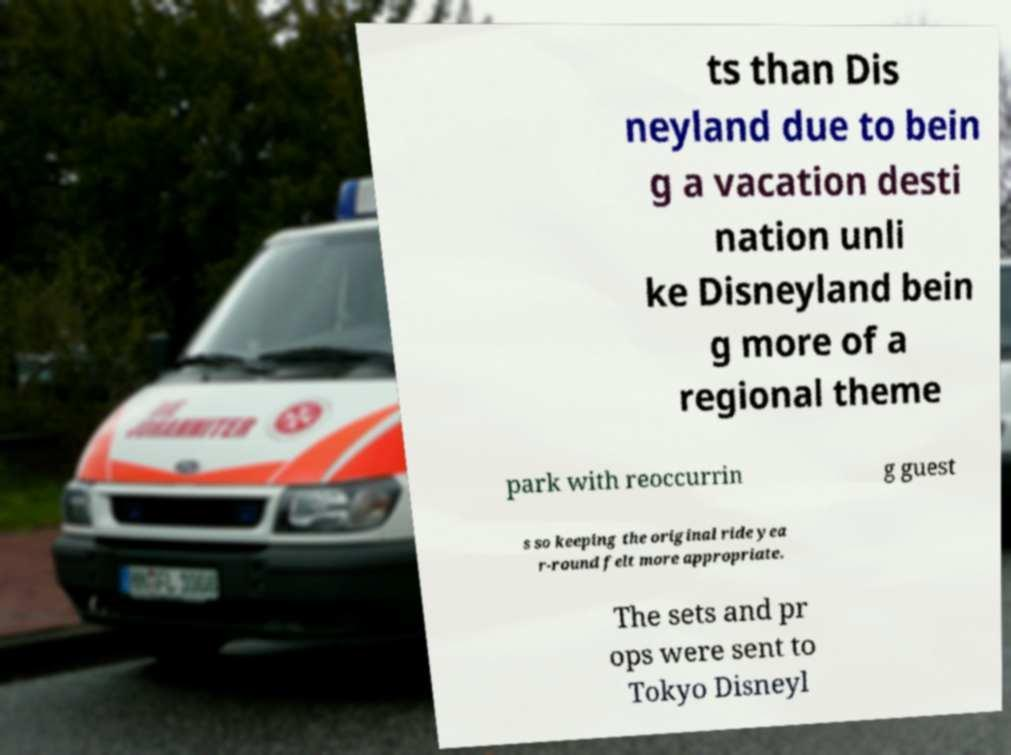Please identify and transcribe the text found in this image. ts than Dis neyland due to bein g a vacation desti nation unli ke Disneyland bein g more of a regional theme park with reoccurrin g guest s so keeping the original ride yea r-round felt more appropriate. The sets and pr ops were sent to Tokyo Disneyl 